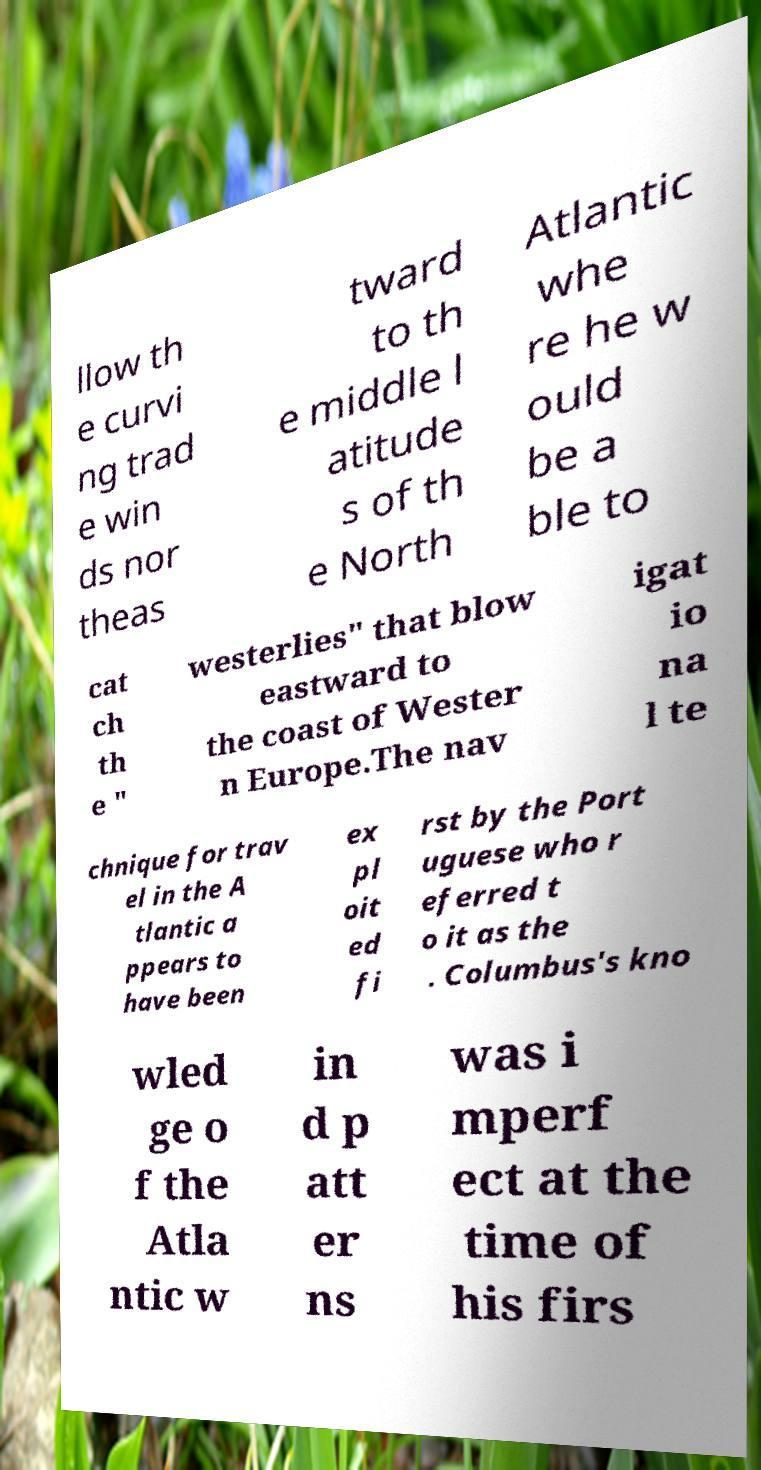Please identify and transcribe the text found in this image. llow th e curvi ng trad e win ds nor theas tward to th e middle l atitude s of th e North Atlantic whe re he w ould be a ble to cat ch th e " westerlies" that blow eastward to the coast of Wester n Europe.The nav igat io na l te chnique for trav el in the A tlantic a ppears to have been ex pl oit ed fi rst by the Port uguese who r eferred t o it as the . Columbus's kno wled ge o f the Atla ntic w in d p att er ns was i mperf ect at the time of his firs 